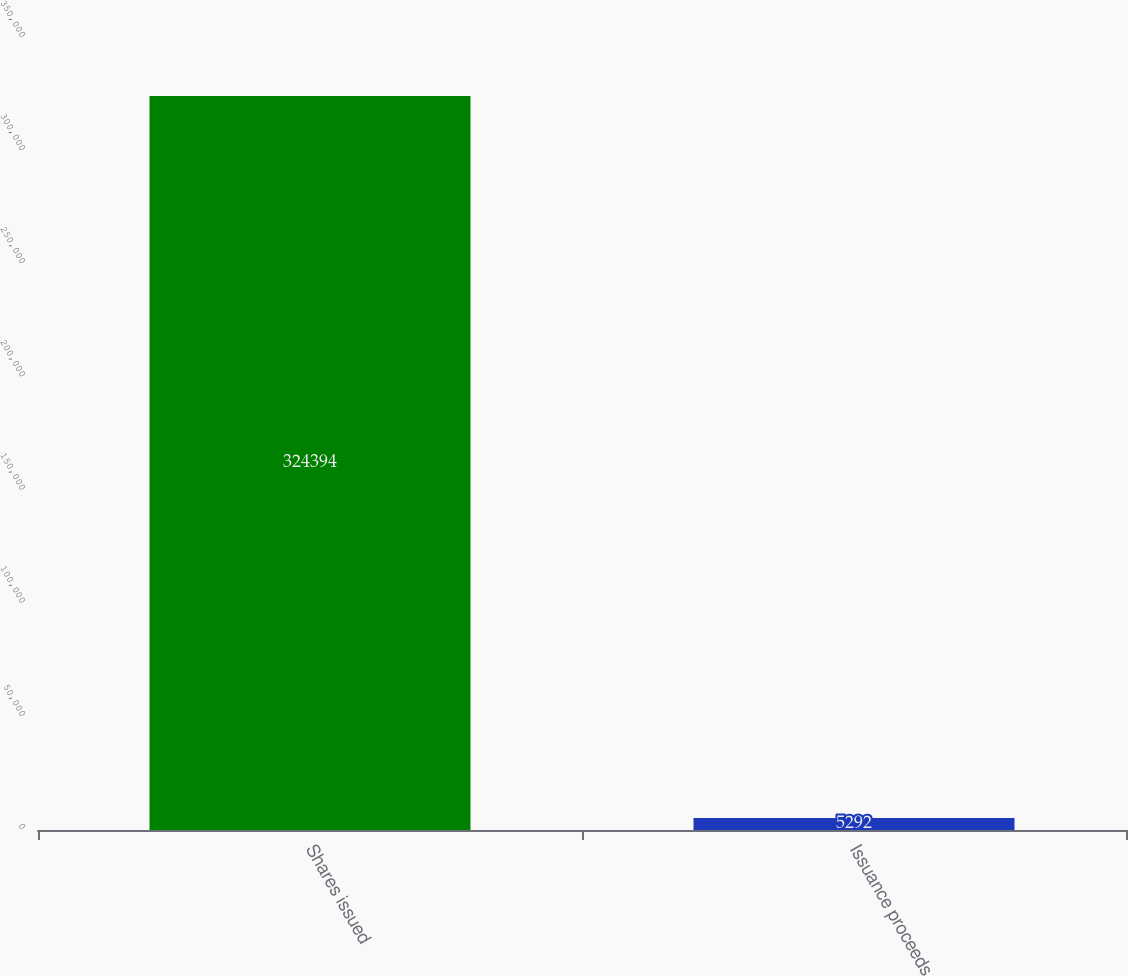<chart> <loc_0><loc_0><loc_500><loc_500><bar_chart><fcel>Shares issued<fcel>Issuance proceeds<nl><fcel>324394<fcel>5292<nl></chart> 